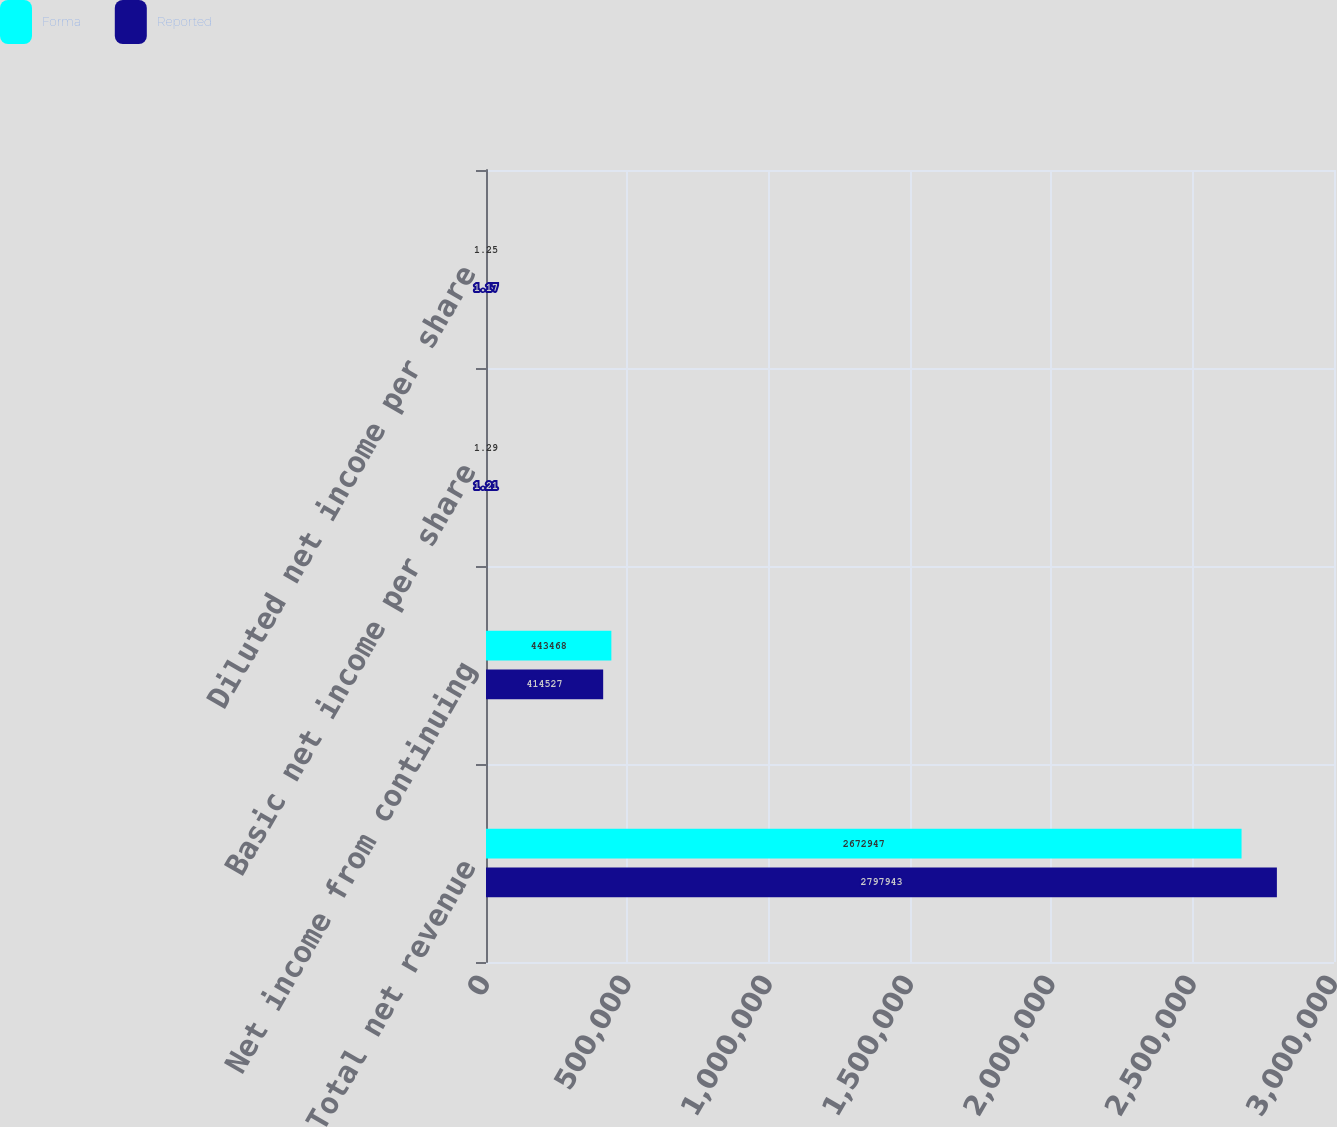Convert chart. <chart><loc_0><loc_0><loc_500><loc_500><stacked_bar_chart><ecel><fcel>Total net revenue<fcel>Net income from continuing<fcel>Basic net income per share<fcel>Diluted net income per share<nl><fcel>Forma<fcel>2.67295e+06<fcel>443468<fcel>1.29<fcel>1.25<nl><fcel>Reported<fcel>2.79794e+06<fcel>414527<fcel>1.21<fcel>1.17<nl></chart> 